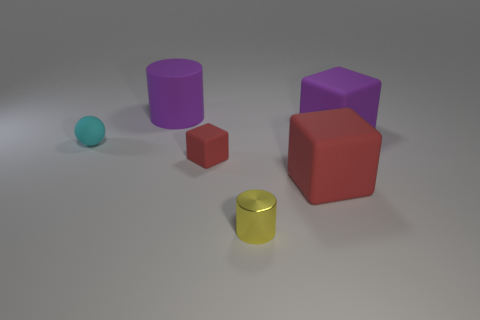Is there anything else that has the same shape as the tiny cyan matte thing?
Offer a terse response. No. Is there anything else that is the same material as the yellow cylinder?
Your response must be concise. No. How many objects are matte things that are in front of the large matte cylinder or purple things that are to the right of the yellow object?
Offer a terse response. 4. There is a matte thing left of the big matte cylinder; what is its color?
Ensure brevity in your answer.  Cyan. Are there any large rubber things left of the big purple rubber object to the right of the tiny red cube?
Keep it short and to the point. Yes. Are there fewer big things than tiny cyan objects?
Provide a succinct answer. No. The cylinder in front of the cylinder behind the big red object is made of what material?
Provide a succinct answer. Metal. Do the cyan rubber thing and the yellow cylinder have the same size?
Keep it short and to the point. Yes. How many objects are blocks or big brown blocks?
Give a very brief answer. 3. How big is the object that is on the right side of the yellow metal cylinder and behind the small cyan object?
Keep it short and to the point. Large. 